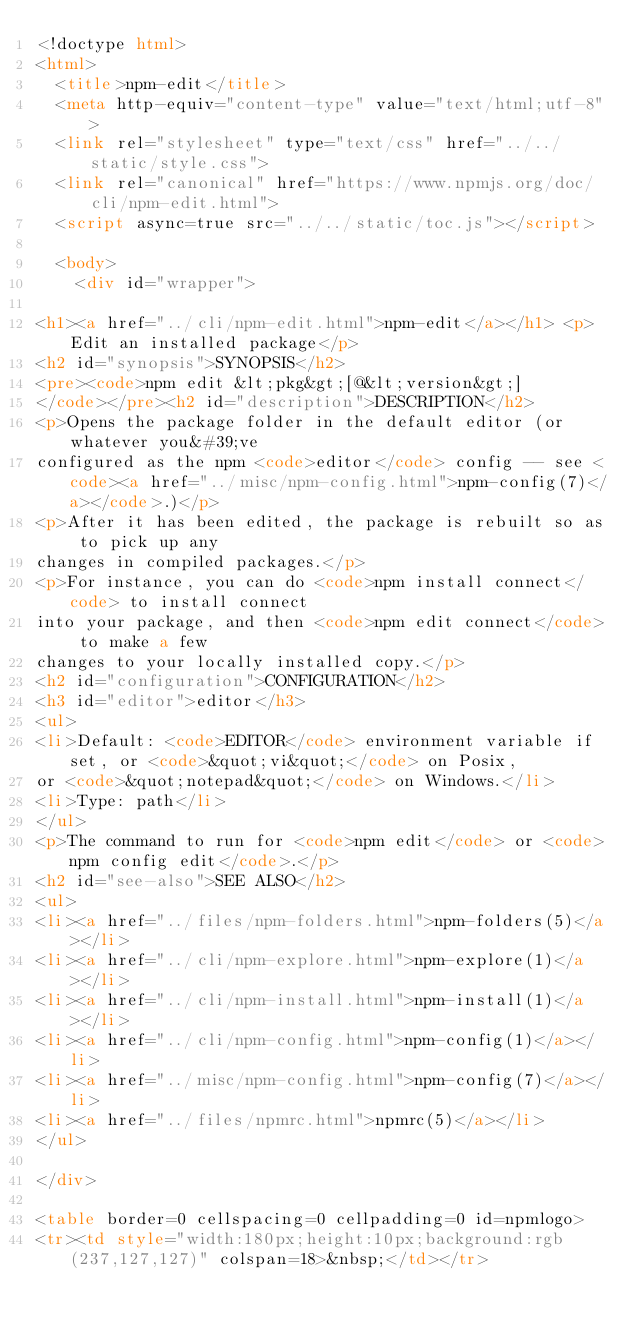Convert code to text. <code><loc_0><loc_0><loc_500><loc_500><_HTML_><!doctype html>
<html>
  <title>npm-edit</title>
  <meta http-equiv="content-type" value="text/html;utf-8">
  <link rel="stylesheet" type="text/css" href="../../static/style.css">
  <link rel="canonical" href="https://www.npmjs.org/doc/cli/npm-edit.html">
  <script async=true src="../../static/toc.js"></script>

  <body>
    <div id="wrapper">

<h1><a href="../cli/npm-edit.html">npm-edit</a></h1> <p>Edit an installed package</p>
<h2 id="synopsis">SYNOPSIS</h2>
<pre><code>npm edit &lt;pkg&gt;[@&lt;version&gt;]
</code></pre><h2 id="description">DESCRIPTION</h2>
<p>Opens the package folder in the default editor (or whatever you&#39;ve
configured as the npm <code>editor</code> config -- see <code><a href="../misc/npm-config.html">npm-config(7)</a></code>.)</p>
<p>After it has been edited, the package is rebuilt so as to pick up any
changes in compiled packages.</p>
<p>For instance, you can do <code>npm install connect</code> to install connect
into your package, and then <code>npm edit connect</code> to make a few
changes to your locally installed copy.</p>
<h2 id="configuration">CONFIGURATION</h2>
<h3 id="editor">editor</h3>
<ul>
<li>Default: <code>EDITOR</code> environment variable if set, or <code>&quot;vi&quot;</code> on Posix,
or <code>&quot;notepad&quot;</code> on Windows.</li>
<li>Type: path</li>
</ul>
<p>The command to run for <code>npm edit</code> or <code>npm config edit</code>.</p>
<h2 id="see-also">SEE ALSO</h2>
<ul>
<li><a href="../files/npm-folders.html">npm-folders(5)</a></li>
<li><a href="../cli/npm-explore.html">npm-explore(1)</a></li>
<li><a href="../cli/npm-install.html">npm-install(1)</a></li>
<li><a href="../cli/npm-config.html">npm-config(1)</a></li>
<li><a href="../misc/npm-config.html">npm-config(7)</a></li>
<li><a href="../files/npmrc.html">npmrc(5)</a></li>
</ul>

</div>

<table border=0 cellspacing=0 cellpadding=0 id=npmlogo>
<tr><td style="width:180px;height:10px;background:rgb(237,127,127)" colspan=18>&nbsp;</td></tr></code> 